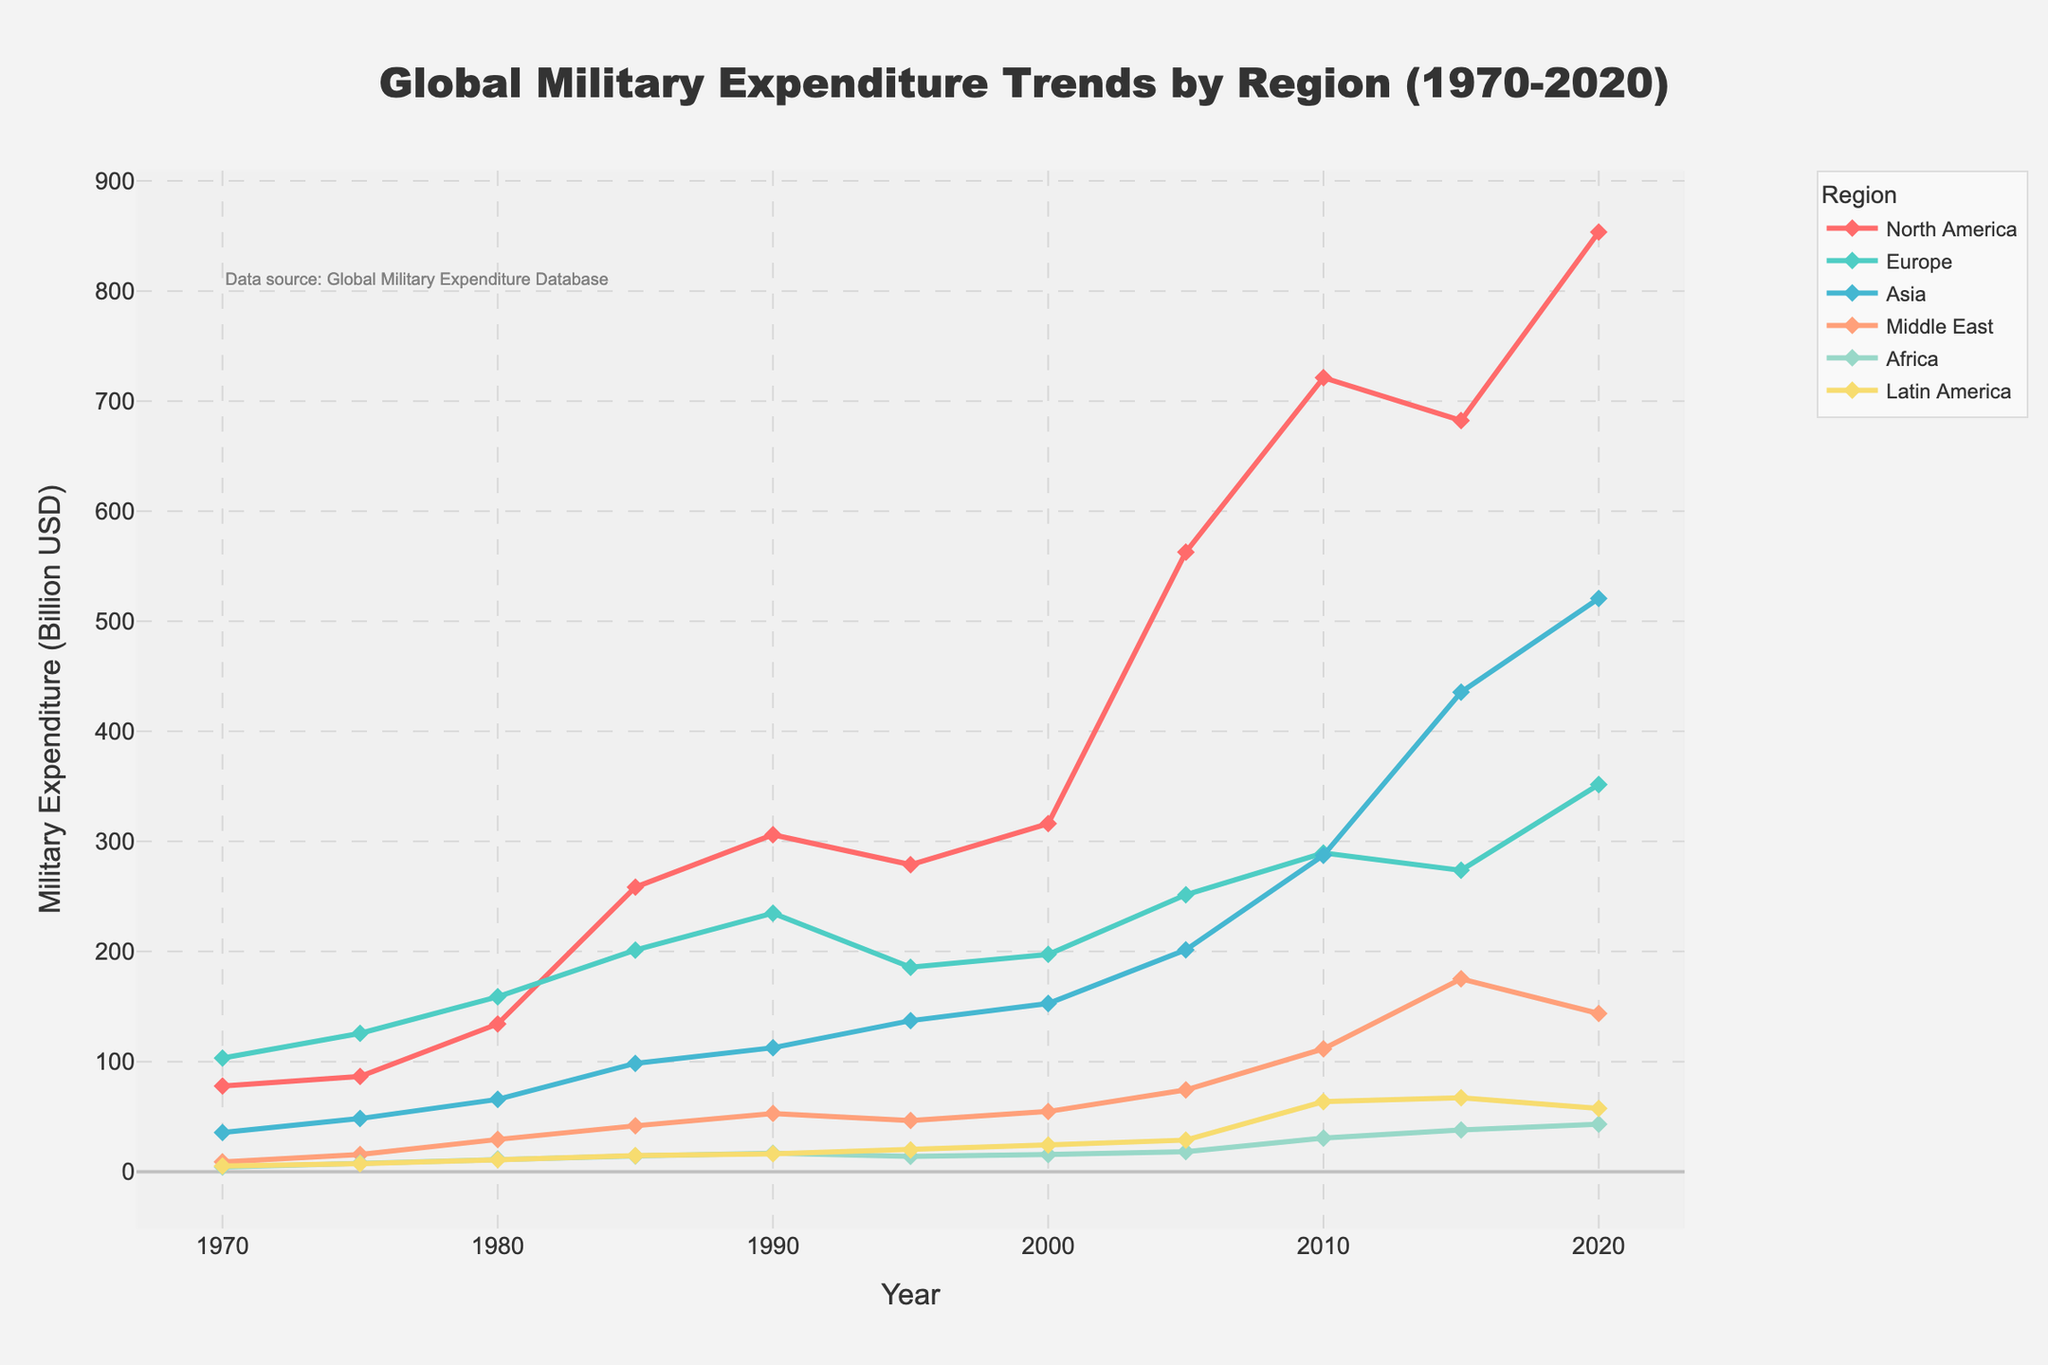what is the trend for North America’s military expenditure from 1970 to 2020? Observing the figure, the trend for North America’s military expenditure shows an initial increase from 77.8 billion USD in 1970 to 306.1 billion USD in 1990, followed by fluctuations and another significant rise to 853.6 billion USD by 2020.
Answer: Increasing Which region had the highest military expenditure in 1985? By examining the different colored lines in the figure for the year 1985, North America’s expenditure at 258.5 billion USD is the highest compared to other regions.
Answer: North America In which year did Asia's military expenditure surpass Europe's for the first time? Examine the intersection points of the lines representing Asia and Europe. The figure shows that Asia’s expenditure, 435.6 billion USD, surpassed Europe’s expenditure, 273.8 billion USD, first in 2015.
Answer: 2015 By how much did Europe’s military expenditure change from 1990 to 2000? Looking at the figures for Europe in 1990 (234.8 billion USD) and 2000 (197.4 billion USD), the change can be calculated as 234.8 - 197.4 = 37.4 billion USD.
Answer: Decreased by 37.4 billion USD What is the average military expenditure for Latin America over the 50 years? Sum the values for Latin America over the provided years: 5.1 + 7.2 + 10.8 + 14.6 + 16.3 + 19.8 + 24.3 + 28.7 + 63.6 + 67.2 + 57.5 = 315.1. Divide by 11 to find the average, 315.1 / 11 ≈ 28.6 billion USD.
Answer: 28.6 billion USD Which region had the smallest military expenditure in 2005, and what was the value? Visually inspecting the lines for the year 2005, Africa’s expenditure was the smallest at 18.2 billion USD.
Answer: Africa, 18.2 billion USD How did the military expenditure for the Middle East change from 1975 to 1985? The figure shows the values for the Middle East at 15.6 billion USD in 1975 and 41.7 billion USD in 1985. The change can be computed as 41.7 - 15.6 = 26.1 billion USD.
Answer: Increased by 26.1 billion USD Find the year when Africa’s military expenditure was at its maximum and state the expenditure value. Reviewing the figure, Africa’s maximum expenditure occurs in 2020 at 43.2 billion USD.
Answer: 2020, 43.2 billion USD Which region observed the steepest increase in military expenditure between 2000 and 2010? By comparing the slopes of the lines from 2000 to 2010, North America shows the steepest increase from 316.2 billion USD to 721.3 billion USD, a change of 405.1 billion USD.
Answer: North America 